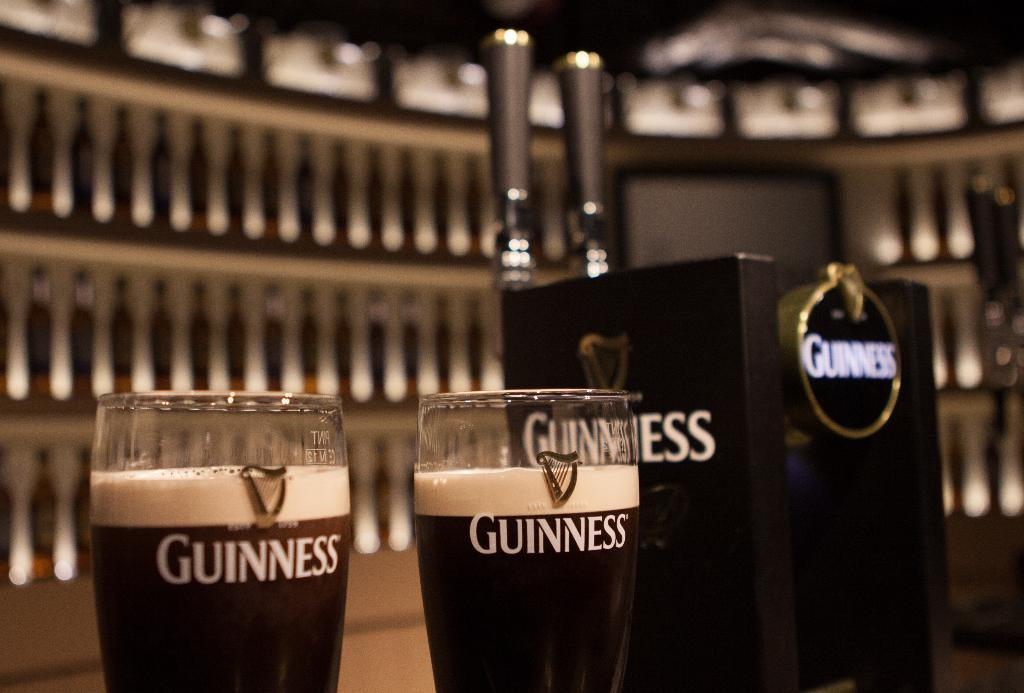<image>
Describe the image concisely. two glasses with the logo 'guinness' standing next to each other 